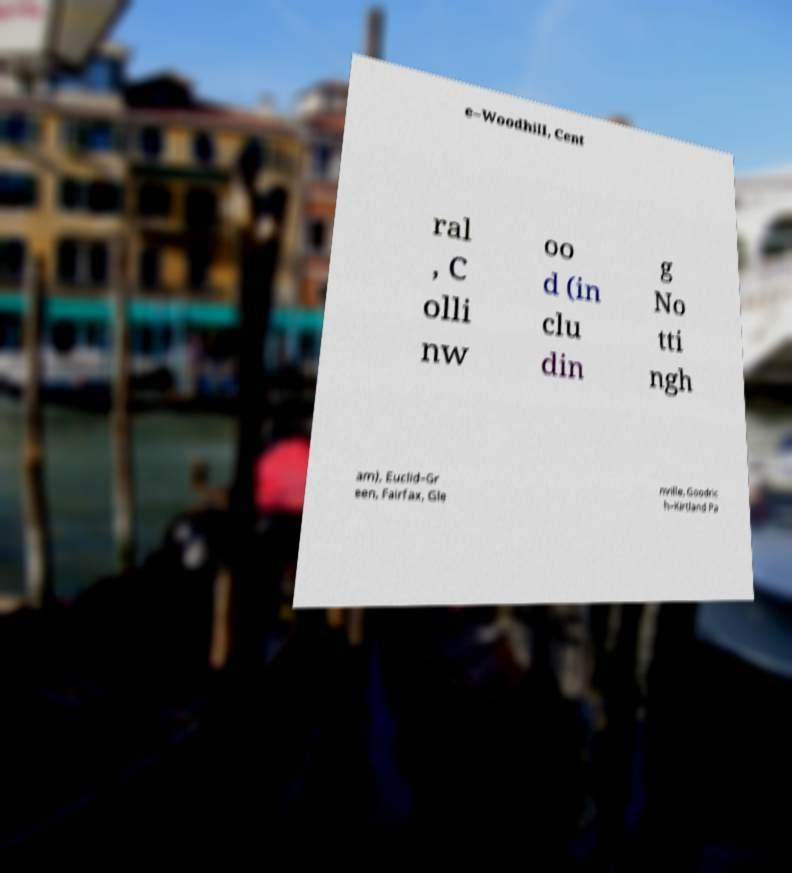Please read and relay the text visible in this image. What does it say? e–Woodhill, Cent ral , C olli nw oo d (in clu din g No tti ngh am), Euclid–Gr een, Fairfax, Gle nville, Goodric h–Kirtland Pa 